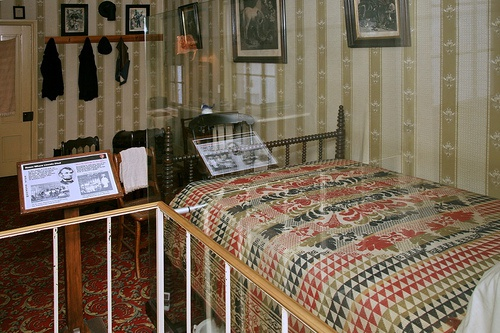Describe the objects in this image and their specific colors. I can see bed in gray and darkgray tones, chair in gray, black, darkgray, and darkgreen tones, chair in gray, black, maroon, and darkgray tones, and chair in gray and black tones in this image. 